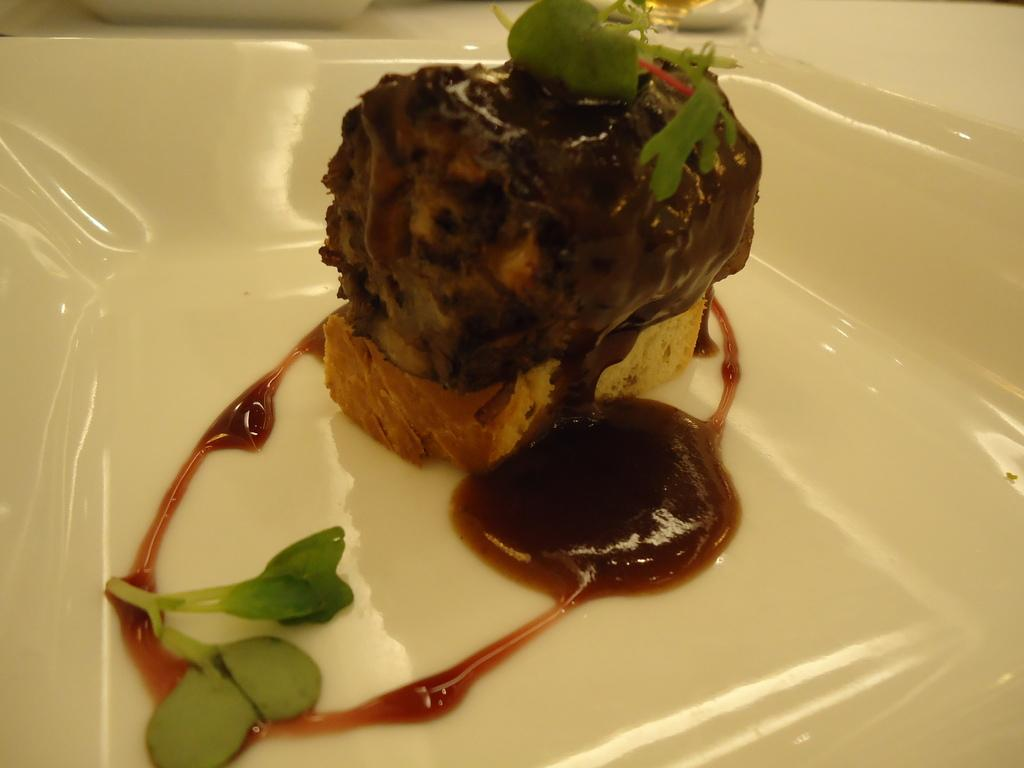What type of food item can be seen in the image? There is a food item in the image, but the specific type is not mentioned in the facts. What is the liquid substance in the image? There is sauce in the image. What type of plant is represented by the small leaves in the image? The facts do not specify the type of plant, only that there are small leaves of a plant in the image. Where are the food items, sauce, and leaves located? The food items, sauce, and leaves are in a plate. What else can be seen on the plate? The facts do not mention any other items on the plate. What objects are on a platform in the image? The facts do not specify which objects are on the platform. What color is the ink on the toe in the image? There is no ink or toe present in the image. How many cherries are on the plate in the image? The facts do not mention any cherries in the image. 